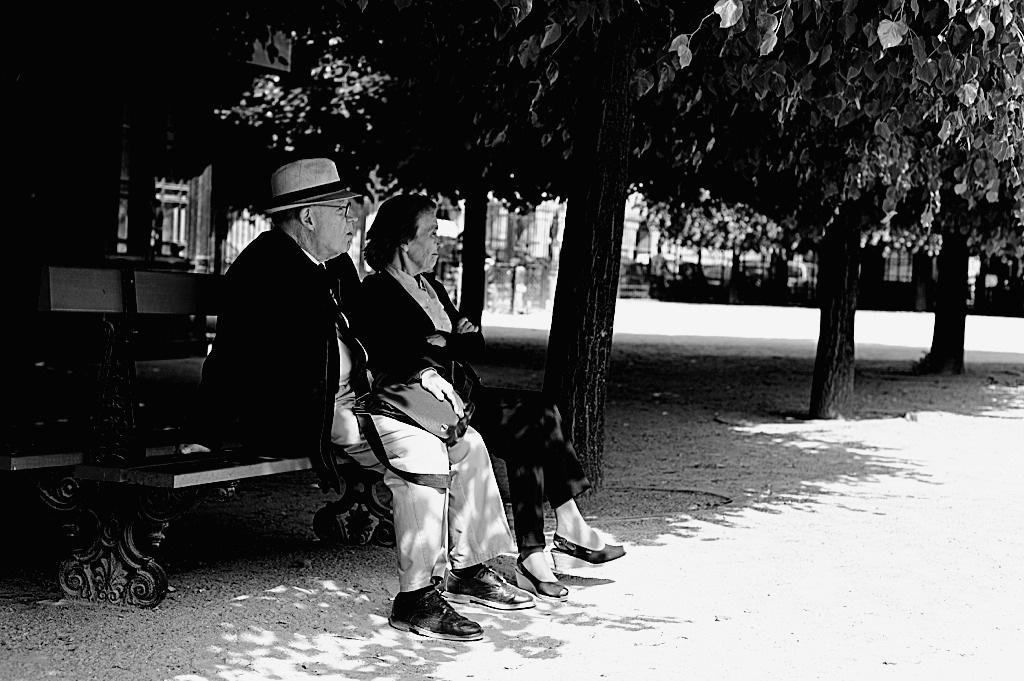Can you describe this image briefly? In this image we can see a man holding bag in his hands and a woman are sitting on a bench. In the center of the image we can see a building. At the top of the image we can see a group of trees. 